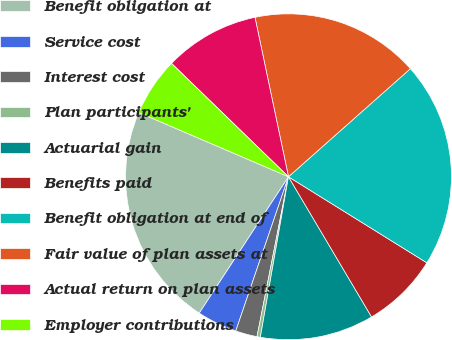Convert chart to OTSL. <chart><loc_0><loc_0><loc_500><loc_500><pie_chart><fcel>Benefit obligation at<fcel>Service cost<fcel>Interest cost<fcel>Plan participants'<fcel>Actuarial gain<fcel>Benefits paid<fcel>Benefit obligation at end of<fcel>Fair value of plan assets at<fcel>Actual return on plan assets<fcel>Employer contributions<nl><fcel>22.23%<fcel>3.98%<fcel>2.15%<fcel>0.33%<fcel>11.28%<fcel>7.63%<fcel>20.4%<fcel>16.75%<fcel>9.45%<fcel>5.8%<nl></chart> 